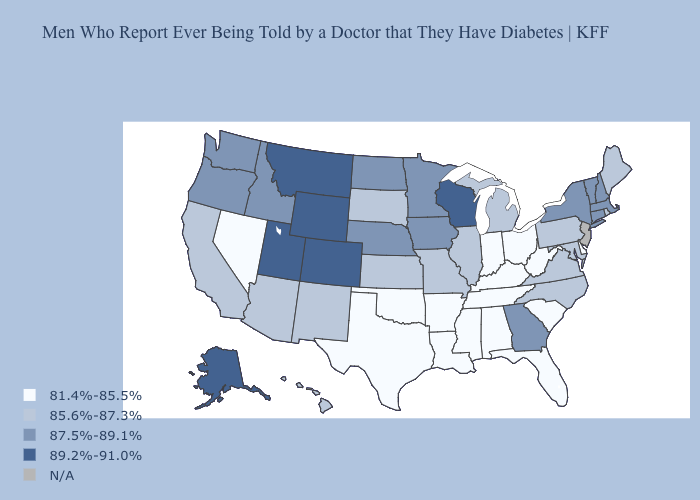Which states hav the highest value in the MidWest?
Give a very brief answer. Wisconsin. What is the highest value in the South ?
Be succinct. 87.5%-89.1%. How many symbols are there in the legend?
Concise answer only. 5. Does the first symbol in the legend represent the smallest category?
Concise answer only. Yes. What is the value of New Mexico?
Short answer required. 85.6%-87.3%. Which states hav the highest value in the South?
Short answer required. Georgia. Is the legend a continuous bar?
Keep it brief. No. What is the value of South Carolina?
Give a very brief answer. 81.4%-85.5%. Among the states that border Indiana , does Michigan have the highest value?
Concise answer only. Yes. Name the states that have a value in the range 81.4%-85.5%?
Give a very brief answer. Alabama, Arkansas, Delaware, Florida, Indiana, Kentucky, Louisiana, Mississippi, Nevada, Ohio, Oklahoma, South Carolina, Tennessee, Texas, West Virginia. What is the highest value in states that border Utah?
Concise answer only. 89.2%-91.0%. Name the states that have a value in the range 81.4%-85.5%?
Keep it brief. Alabama, Arkansas, Delaware, Florida, Indiana, Kentucky, Louisiana, Mississippi, Nevada, Ohio, Oklahoma, South Carolina, Tennessee, Texas, West Virginia. Does Rhode Island have the lowest value in the Northeast?
Write a very short answer. Yes. What is the lowest value in the USA?
Quick response, please. 81.4%-85.5%. 